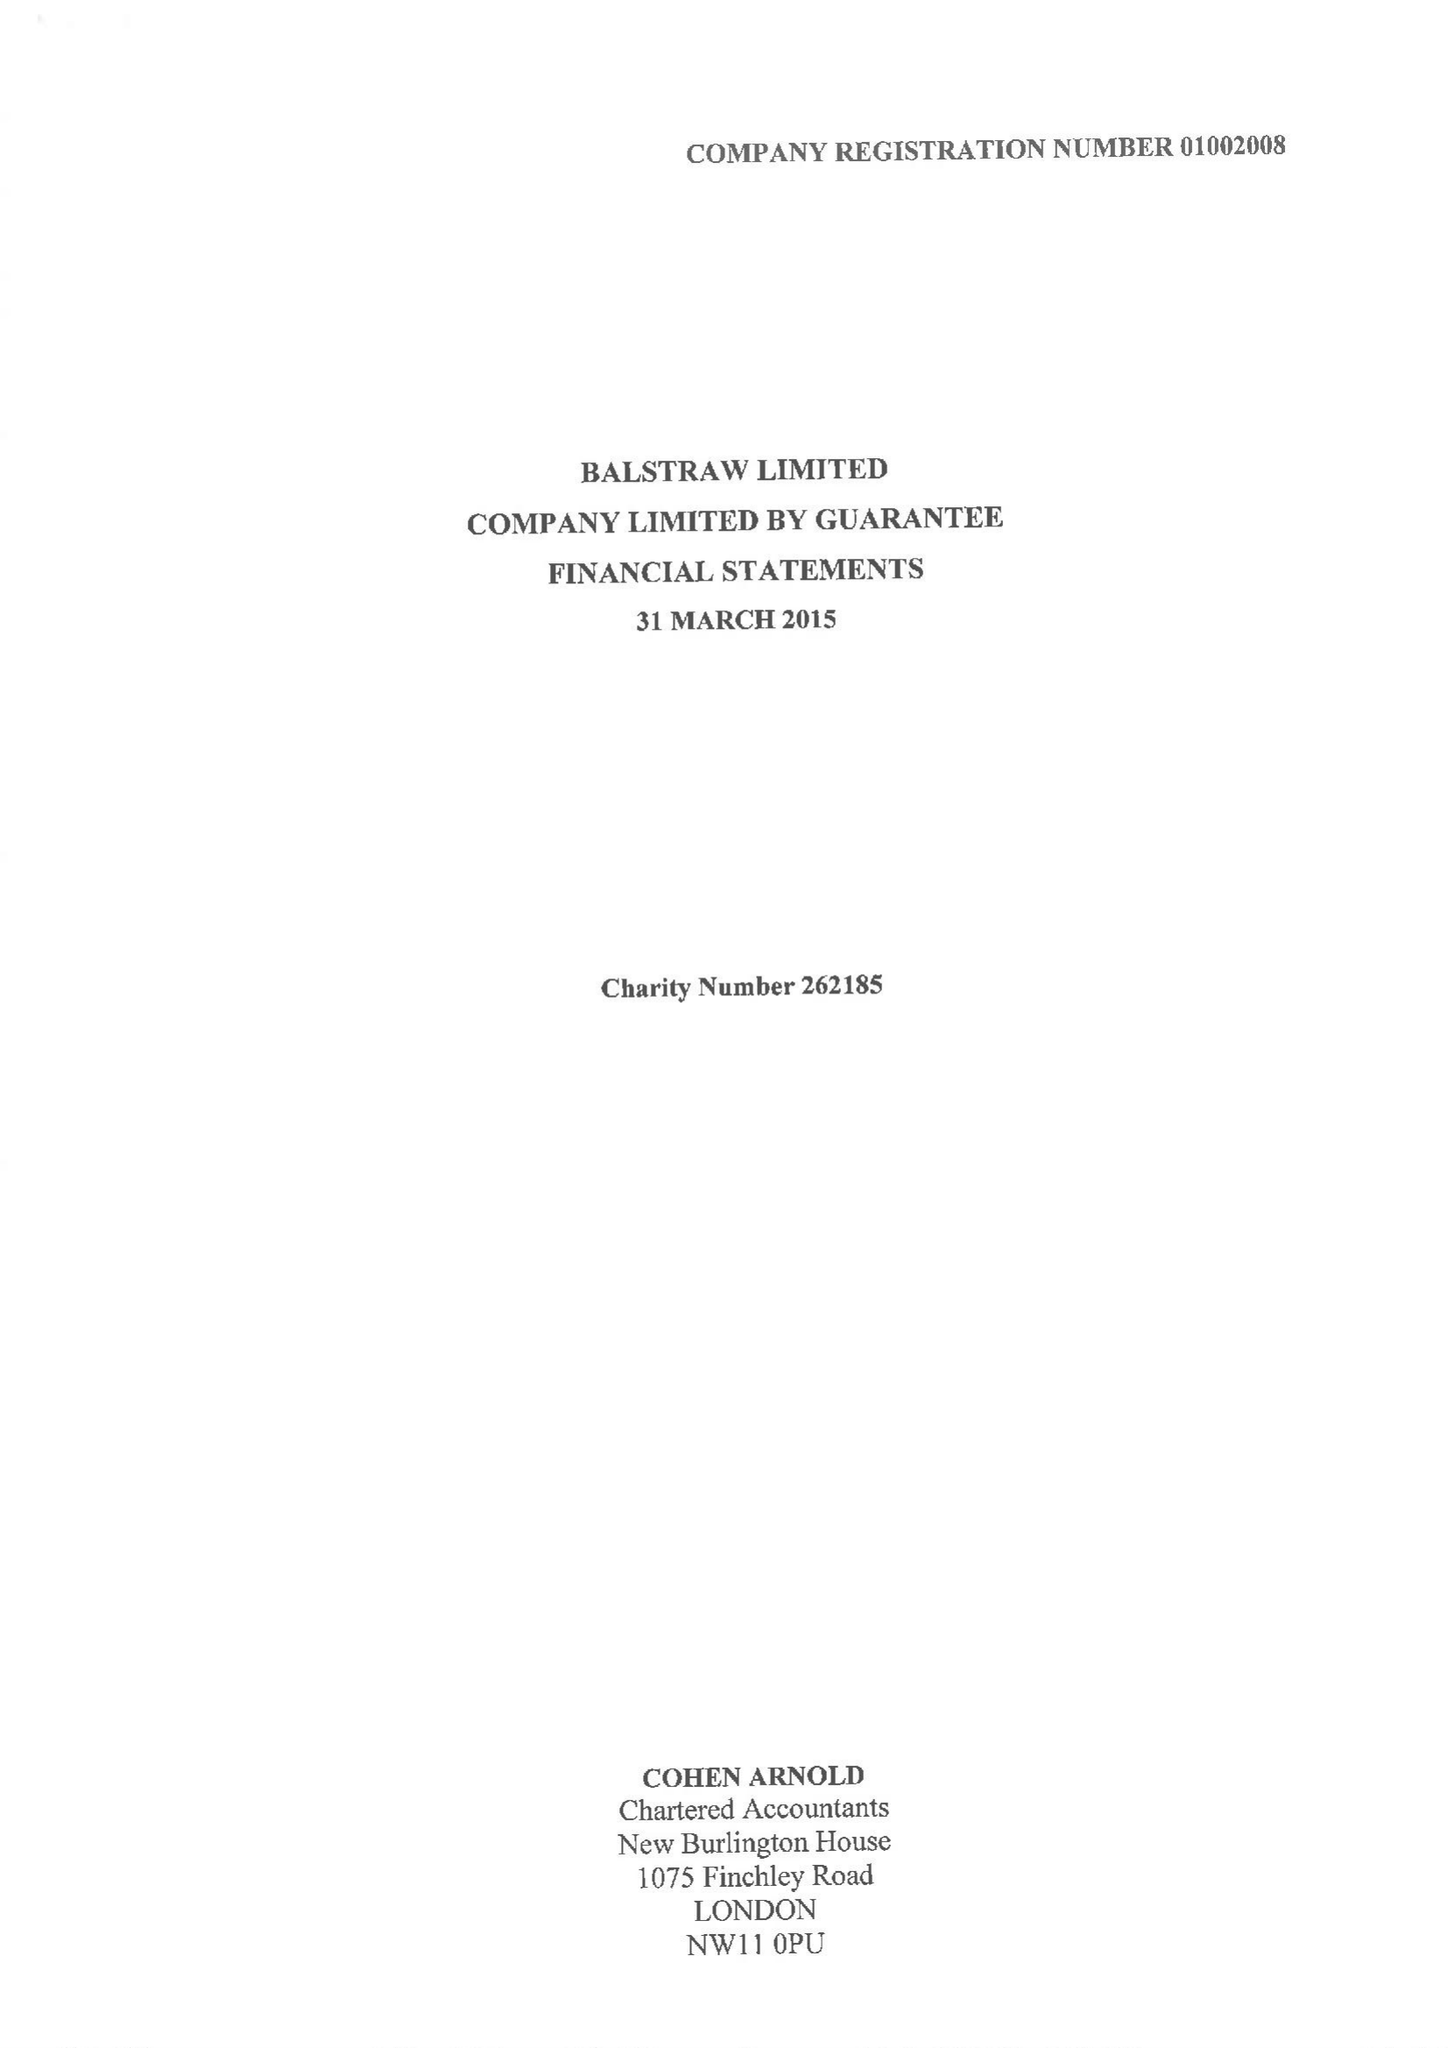What is the value for the charity_number?
Answer the question using a single word or phrase. 262185 